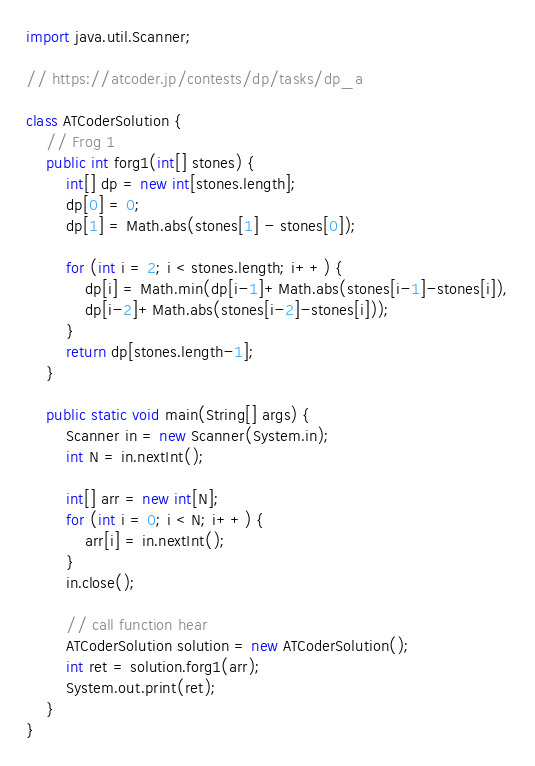<code> <loc_0><loc_0><loc_500><loc_500><_Java_>import java.util.Scanner;

// https://atcoder.jp/contests/dp/tasks/dp_a

class ATCoderSolution {
    // Frog 1
    public int forg1(int[] stones) {
        int[] dp = new int[stones.length];
        dp[0] = 0;
        dp[1] = Math.abs(stones[1] - stones[0]);

        for (int i = 2; i < stones.length; i++) {
            dp[i] = Math.min(dp[i-1]+Math.abs(stones[i-1]-stones[i]),
            dp[i-2]+Math.abs(stones[i-2]-stones[i]));
        }
        return dp[stones.length-1];
    }

    public static void main(String[] args) {
        Scanner in = new Scanner(System.in);
        int N = in.nextInt();

        int[] arr = new int[N];
        for (int i = 0; i < N; i++) {
            arr[i] = in.nextInt();
        }
        in.close();

        // call function hear
        ATCoderSolution solution = new ATCoderSolution();
        int ret = solution.forg1(arr);
        System.out.print(ret);
    }
}</code> 